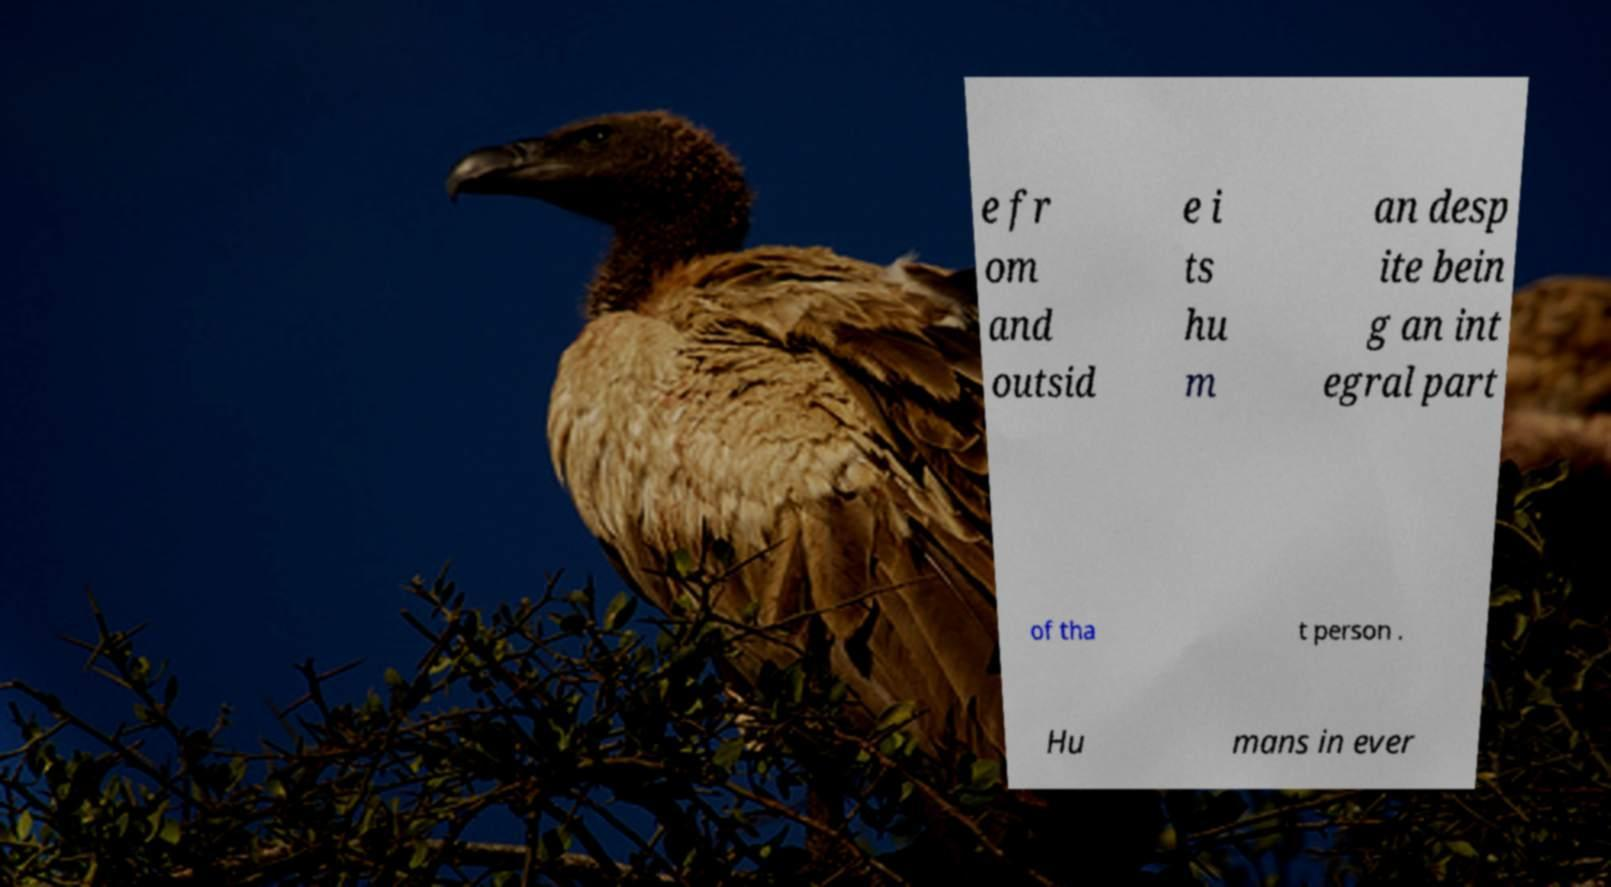For documentation purposes, I need the text within this image transcribed. Could you provide that? e fr om and outsid e i ts hu m an desp ite bein g an int egral part of tha t person . Hu mans in ever 